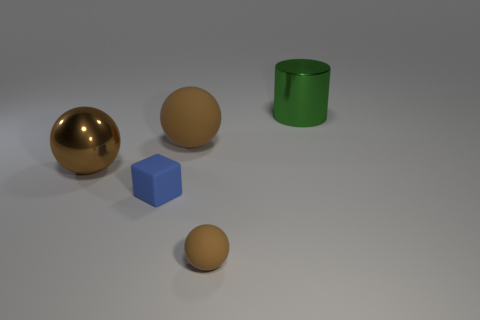Add 4 blue objects. How many objects exist? 9 Subtract all big brown spheres. How many spheres are left? 1 Subtract 1 balls. How many balls are left? 2 Subtract all gray spheres. Subtract all gray cylinders. How many spheres are left? 3 Subtract all blocks. How many objects are left? 4 Add 5 large brown metal cylinders. How many large brown metal cylinders exist? 5 Subtract 0 gray cylinders. How many objects are left? 5 Subtract all spheres. Subtract all metallic cylinders. How many objects are left? 1 Add 4 rubber objects. How many rubber objects are left? 7 